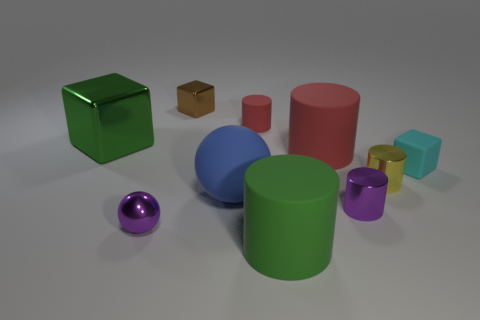There is a big matte thing on the left side of the green cylinder; what color is it?
Your response must be concise. Blue. What number of other objects are there of the same material as the big cube?
Provide a succinct answer. 4. Is the number of purple metallic things that are on the right side of the small matte cylinder greater than the number of large matte objects to the left of the purple shiny ball?
Offer a very short reply. Yes. What number of tiny shiny cylinders are to the left of the big blue ball?
Offer a very short reply. 0. Are the brown block and the green thing that is behind the green rubber cylinder made of the same material?
Offer a very short reply. Yes. Do the big green block and the big green cylinder have the same material?
Ensure brevity in your answer.  No. There is a tiny purple object that is on the right side of the small red cylinder; is there a large green cylinder behind it?
Ensure brevity in your answer.  No. How many things are behind the tiny purple cylinder and left of the green matte cylinder?
Provide a succinct answer. 4. The purple metallic object on the left side of the large blue matte thing has what shape?
Provide a short and direct response. Sphere. How many yellow things are the same size as the yellow cylinder?
Ensure brevity in your answer.  0. 